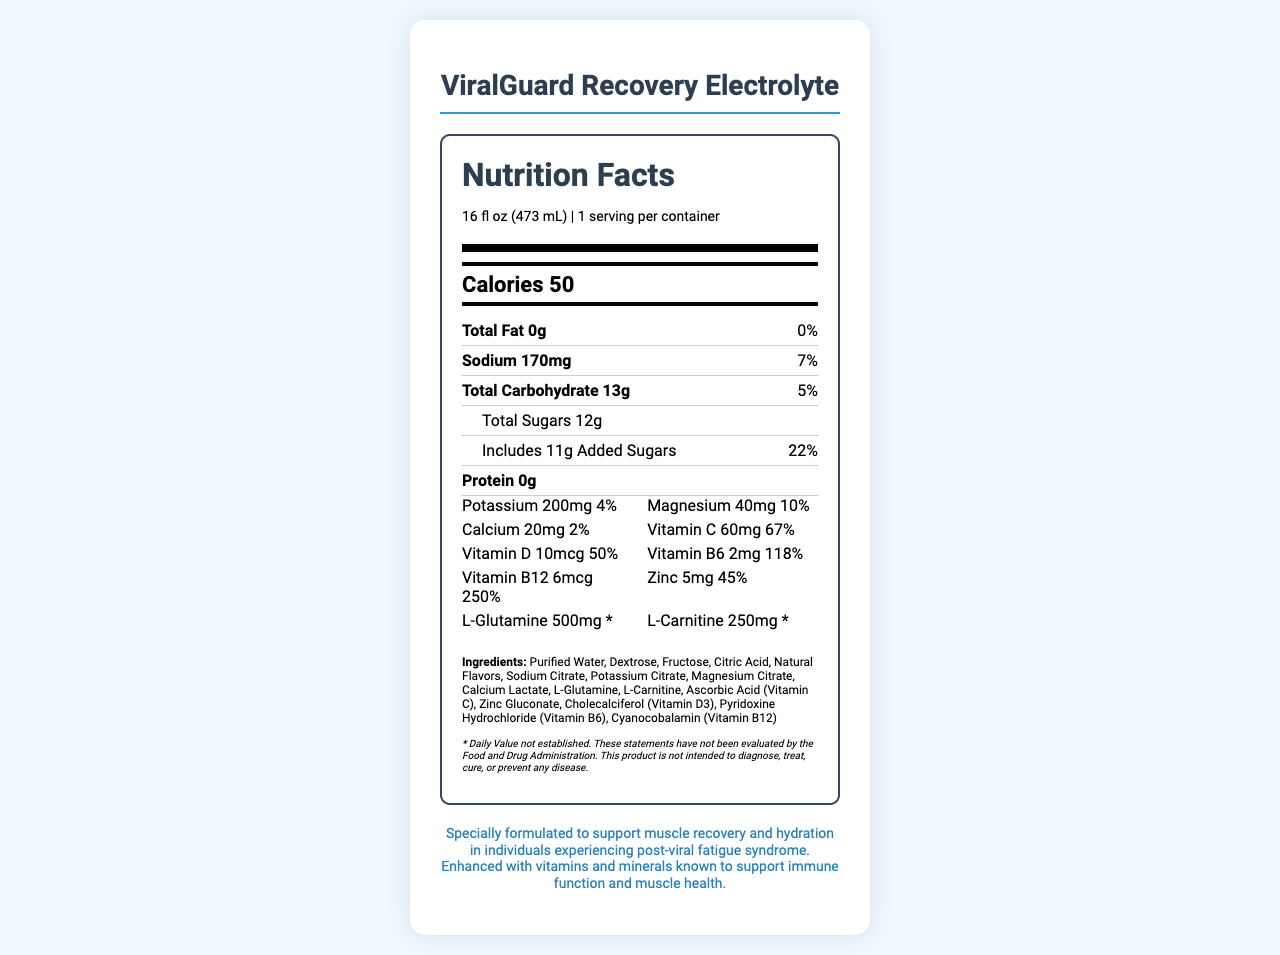what is the serving size of ViralGuard Recovery Electrolyte? The document specifies the serving size as "16 fl oz (473 mL)".
Answer: 16 fl oz (473 mL) how many calories are in one serving of ViralGuard Recovery Electrolyte? The document lists the calorie content as 50.
Answer: 50 what is the percentage daily value of Vitamin B12 in this drink? The document indicates that the daily value of Vitamin B12 is 250%.
Answer: 250% how much sodium does one serving contain? The document states that one serving contains 170mg of sodium.
Answer: 170mg what are the two main sugars listed in the ingredients? The ingredient list includes Dextrose and Fructose.
Answer: Dextrose and Fructose which vitamin has the highest daily value percentage in this beverage? A. Vitamin C B. Vitamin B6 C. Vitamin B12 D. Vitamin D The daily value of Vitamin B12 is 250%, which is the highest among the listed vitamins.
Answer: C. Vitamin B12 what percentage of the daily value of Calcium does one serving provide? A. 2% B. 4% C. 10% D. 50% The document specifies that the daily value of Calcium is 2%.
Answer: A. 2% is this product intended to diagnose, treat, cure, or prevent any disease? The disclaimer states that the product is not intended to diagnose, treat, cure, or prevent any disease.
Answer: No what is the main purpose of ViralGuard Recovery Electrolyte as described in the document? The additional info states that the product is formulated for muscle recovery and hydration for individuals with post-viral fatigue syndrome.
Answer: To support muscle recovery and hydration in individuals experiencing post-viral fatigue syndrome. are there any allergens associated with ViralGuard Recovery Electrolyte? The document mentions that it is produced in a facility that processes soy and milk products.
Answer: Yes how much potassium is in one serving of this drink? The document lists 200mg of potassium per serving.
Answer: 200mg explain why this drink might be beneficial for someone recovering from a virus The document's nutrient content and additional info suggest that the combination of hydration and immune-supporting ingredients can aid in recovery from virus-induced muscle weakness and dehydration.
Answer: This drink might be beneficial because it contains electrolytes like sodium and potassium to help with hydration, as well as vitamins and minerals such as Vitamin C, Vitamin D, and Zinc to support immune function and muscle recovery. Additionally, it includes L-Glutamine and L-Carnitine, which are known for their roles in muscle health. describe the entire document's content in one or two sentences The document combines the nutrition information and purpose of the electrolyte drink, targeting the long-term effects of viruses on physical performance.
Answer: The document details the nutrition facts and ingredient list of ViralGuard Recovery Electrolyte, a vitamin-fortified drink designed to support muscle recovery and hydration for individuals experiencing post-viral fatigue. It includes information on serving size, calories, macronutrients, vitamins, minerals, and additional ingredients, along with allergen info, storage instructions, and a disclaimer. what is the serving size for children under 12? The document does not provide any specific serving size information for children under 12.
Answer: Cannot be determined 